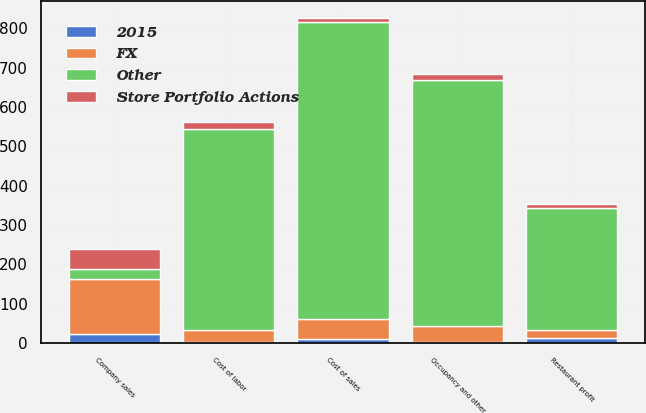Convert chart. <chart><loc_0><loc_0><loc_500><loc_500><stacked_bar_chart><ecel><fcel>Company sales<fcel>Cost of sales<fcel>Cost of labor<fcel>Occupancy and other<fcel>Restaurant profit<nl><fcel>Other<fcel>24<fcel>757<fcel>513<fcel>625<fcel>308<nl><fcel>2015<fcel>24<fcel>10<fcel>3<fcel>3<fcel>14<nl><fcel>Store Portfolio Actions<fcel>52<fcel>10<fcel>16<fcel>15<fcel>11<nl><fcel>FX<fcel>139<fcel>50<fcel>29<fcel>40<fcel>20<nl></chart> 